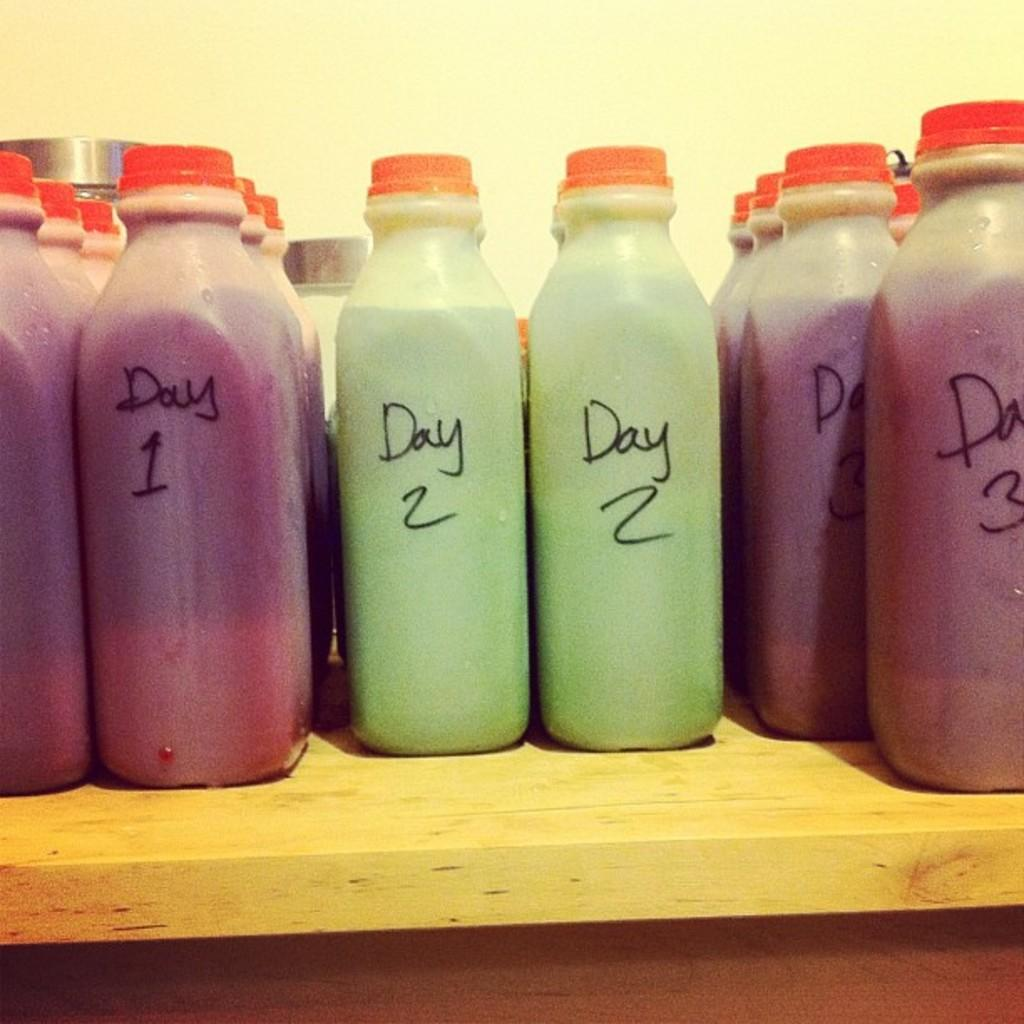Provide a one-sentence caption for the provided image. bottles of juice read Day 1, Day 2 and Day 3. 